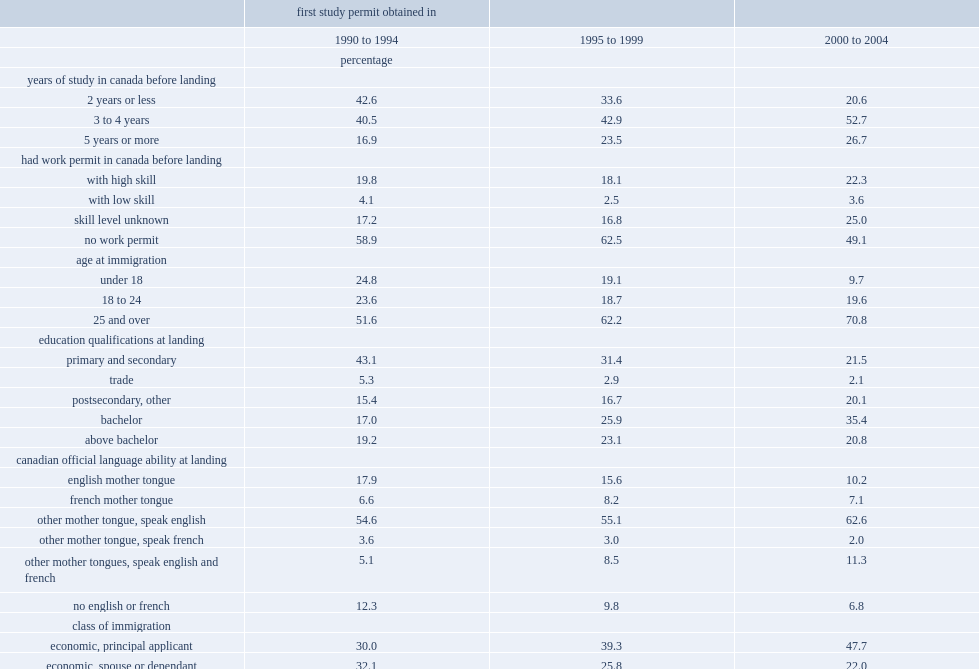Among those from the early 1990s cohorts,what is the proportion of those who completed at least three years of study in canada? 57.4. Among those from the early 2000s cohorts,what is the proportion of those who completed at least three years of study in canada? 79.4. Among those from the early 1990s cohorts, who were previously international students,what is the proportion of those aged 25 or over at landing? 51.6. Among those from the early 2000s cohorts, who were previously international students,what is the proportion of those aged 25 or over at landing? 70.8. Among those from the early 1900s cohorts, what is the proportion of the landed immigrants who had a university degree at landing? 36.2. Among those from the early 2000s cohorts, what is the proportion of the landed immigrants who had a university degree at landing? 56.2. Among those from the early 1990s cohorts, what is the proportion of the landed immigrants who who became permanent residents as principal applicants in the economic class? 30.0. Among those from the early 2000s cohorts, what is the proportion of the landed immigrants who who became permanent residents as principal applicants in the economic class? 47.7. 